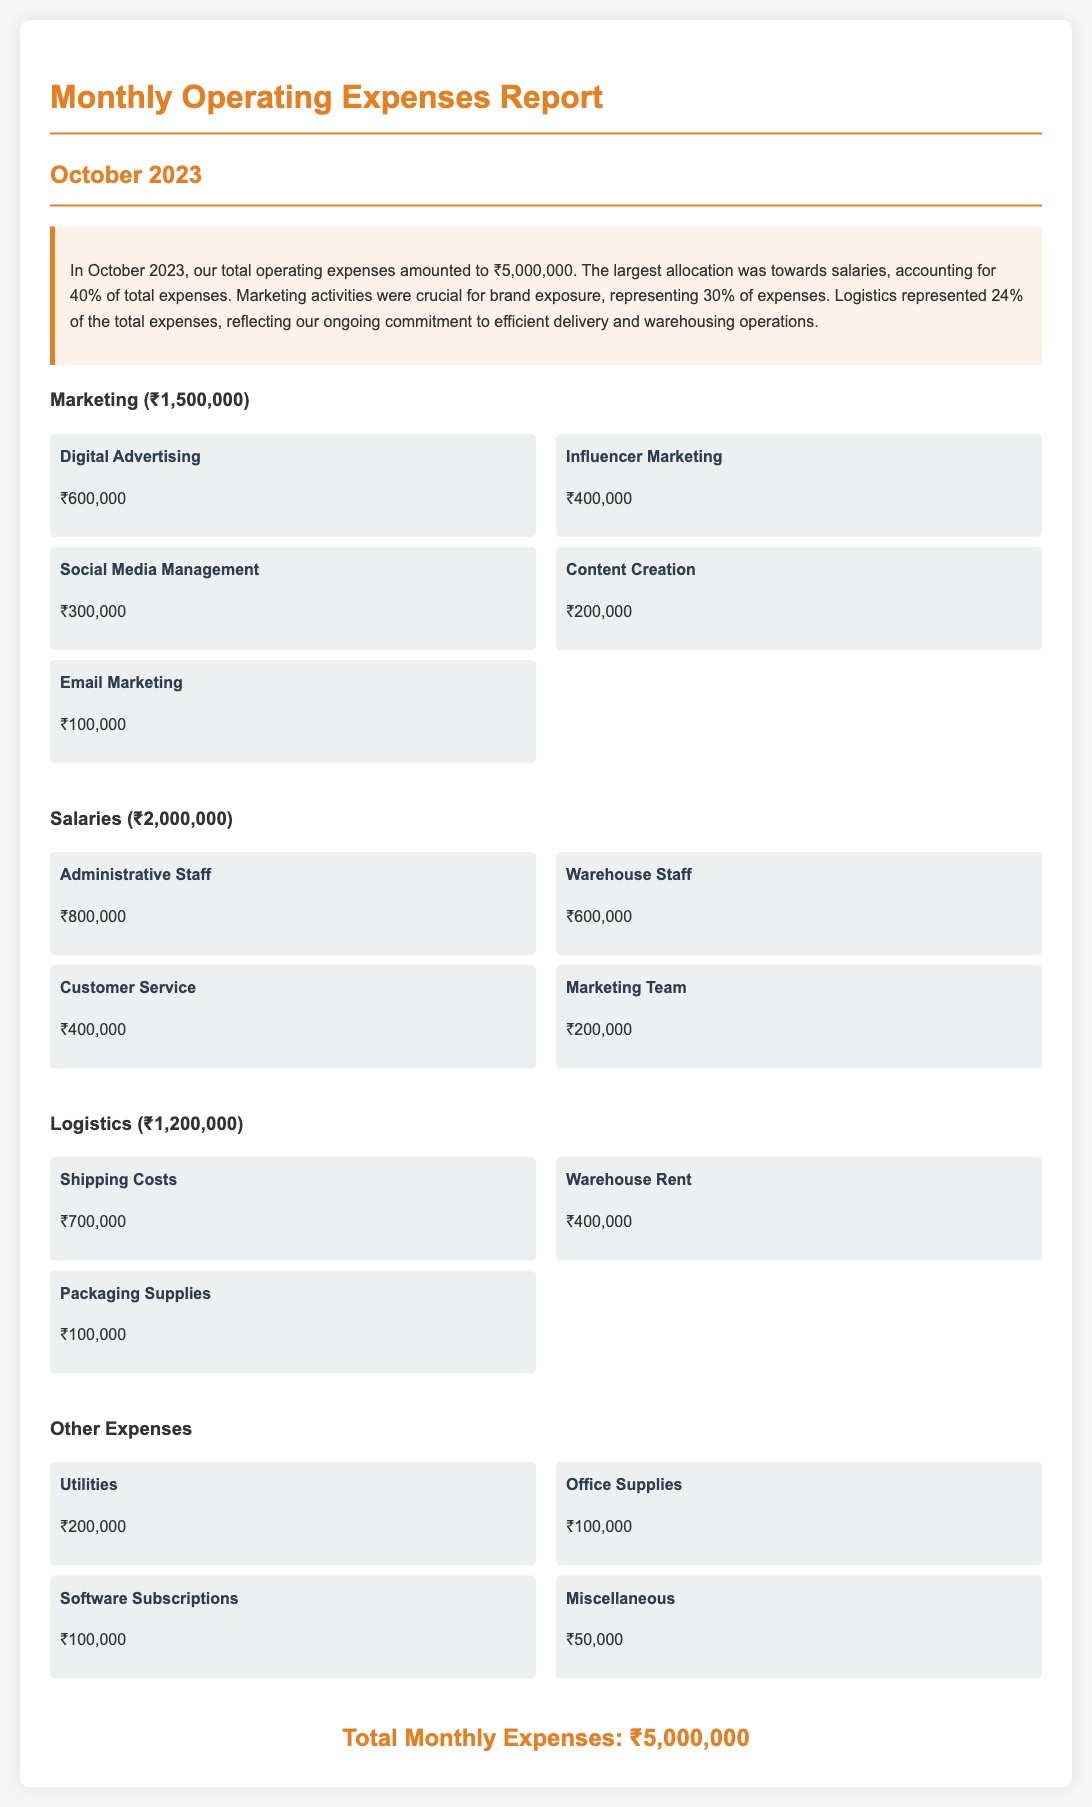what is the total operating expenses for October 2023? The total operating expenses are stated in the summary section of the document, which amounts to ₹5,000,000.
Answer: ₹5,000,000 what percentage of total expenses is allocated to marketing? The summary indicates that marketing expenses represent 30% of total expenses.
Answer: 30% how much was spent on shipping costs? The logistics section specifically lists shipping costs as ₹700,000.
Answer: ₹700,000 what is the allocation for salaries? The salaries section shows that the total allocation for salaries is ₹2,000,000.
Answer: ₹2,000,000 which category had the highest expenditure? The document details that salaries accounted for 40% of total expenses, making it the highest expenditure category.
Answer: Salaries how much was spent on digital advertising? The marketing breakdown shows that the expense for digital advertising is ₹600,000.
Answer: ₹600,000 what is the total amount allocated for logistics? The logistics section mentions the total allocation as ₹1,200,000.
Answer: ₹1,200,000 how much was allocated for email marketing? The expense item for email marketing specifies an allocation of ₹100,000.
Answer: ₹100,000 what percentage of the total expenses is assigned to logistics? The summary states that logistics expenses account for 24% of total expenses.
Answer: 24% 